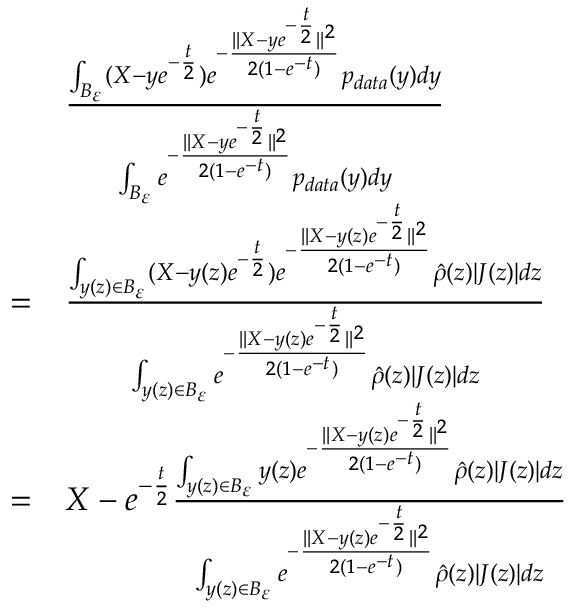<formula> <loc_0><loc_0><loc_500><loc_500>\begin{array} { r l } & { \frac { \int _ { B _ { \varepsilon } } ( X - y e ^ { - \frac { t } { 2 } } ) e ^ { - \frac { \| X - y e ^ { - \frac { t } { 2 } } \| ^ { 2 } } { 2 ( 1 - e ^ { - t } ) } } p _ { d a t a } ( y ) d y } { \int _ { B _ { \varepsilon } } e ^ { - \frac { \| X - y e ^ { - \frac { t } { 2 } } \| ^ { 2 } } { 2 ( 1 - e ^ { - t } ) } } p _ { d a t a } ( y ) d y } } \\ { = } & { \frac { \int _ { y ( z ) \in B _ { \varepsilon } } ( X - y ( z ) e ^ { - \frac { t } { 2 } } ) e ^ { - \frac { \| X - y ( z ) e ^ { - \frac { t } { 2 } } \| ^ { 2 } } { 2 ( 1 - e ^ { - t } ) } } \hat { \rho } ( z ) | J ( z ) | d z } { \int _ { y ( z ) \in B _ { \varepsilon } } e ^ { - \frac { \| X - y ( z ) e ^ { - \frac { t } { 2 } } \| ^ { 2 } } { 2 ( 1 - e ^ { - t } ) } } \hat { \rho } ( z ) | J ( z ) | d z } } \\ { = } & { X - e ^ { - \frac { t } { 2 } } \frac { \int _ { y ( z ) \in B _ { \varepsilon } } y ( z ) e ^ { - \frac { \| X - y ( z ) e ^ { - \frac { t } { 2 } } \| ^ { 2 } } { 2 ( 1 - e ^ { - t } ) } } \hat { \rho } ( z ) | J ( z ) | d z } { \int _ { y ( z ) \in B _ { \varepsilon } } e ^ { - \frac { \| X - y ( z ) e ^ { - \frac { t } { 2 } } \| ^ { 2 } } { 2 ( 1 - e ^ { - t } ) } } \hat { \rho } ( z ) | J ( z ) | d z } } \end{array}</formula> 